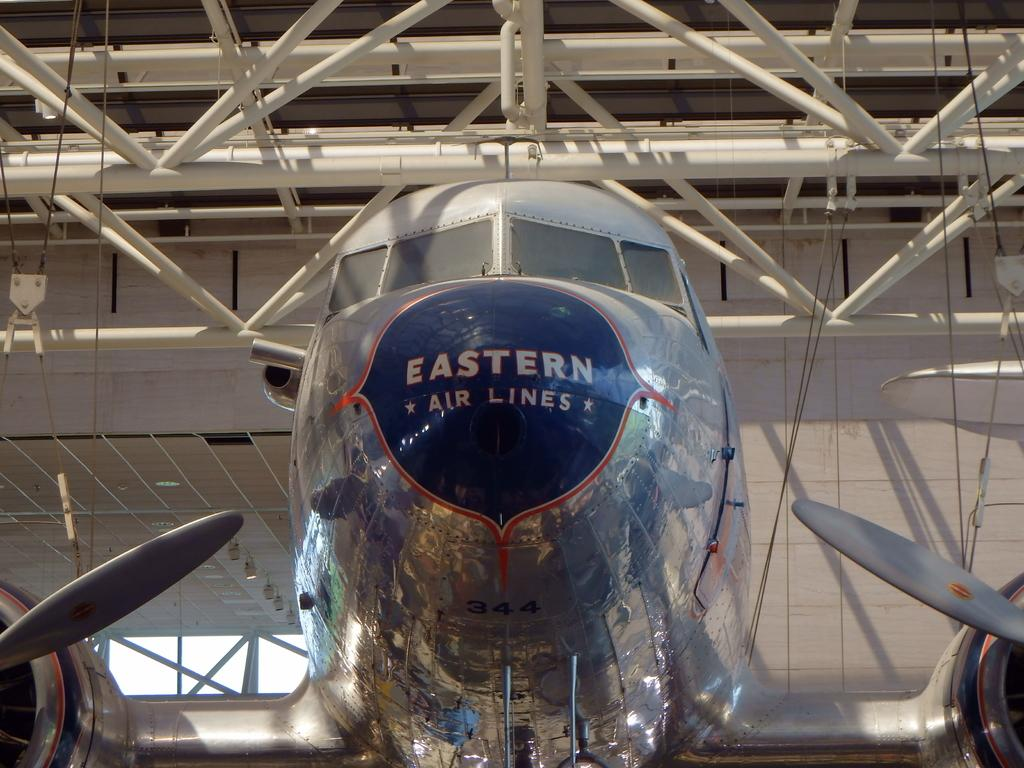Provide a one-sentence caption for the provided image. A front on image of an Easter Airlines prop Jet in an aircraft hangar. 